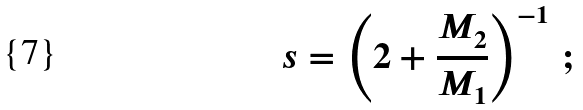<formula> <loc_0><loc_0><loc_500><loc_500>s = \left ( 2 + \frac { M _ { 2 } } { M _ { 1 } } \right ) ^ { - 1 } \, ;</formula> 